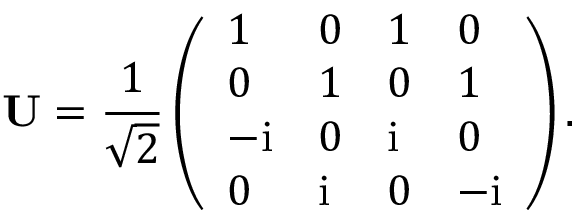<formula> <loc_0><loc_0><loc_500><loc_500>\mathbf U = \frac { 1 } { \sqrt { 2 } } \left ( \begin{array} { l l l l } { 1 } & { 0 } & { 1 } & { 0 } \\ { 0 } & { 1 } & { 0 } & { 1 } \\ { - i } & { 0 } & { i } & { 0 } \\ { 0 } & { i } & { 0 } & { - i } \end{array} \right ) .</formula> 